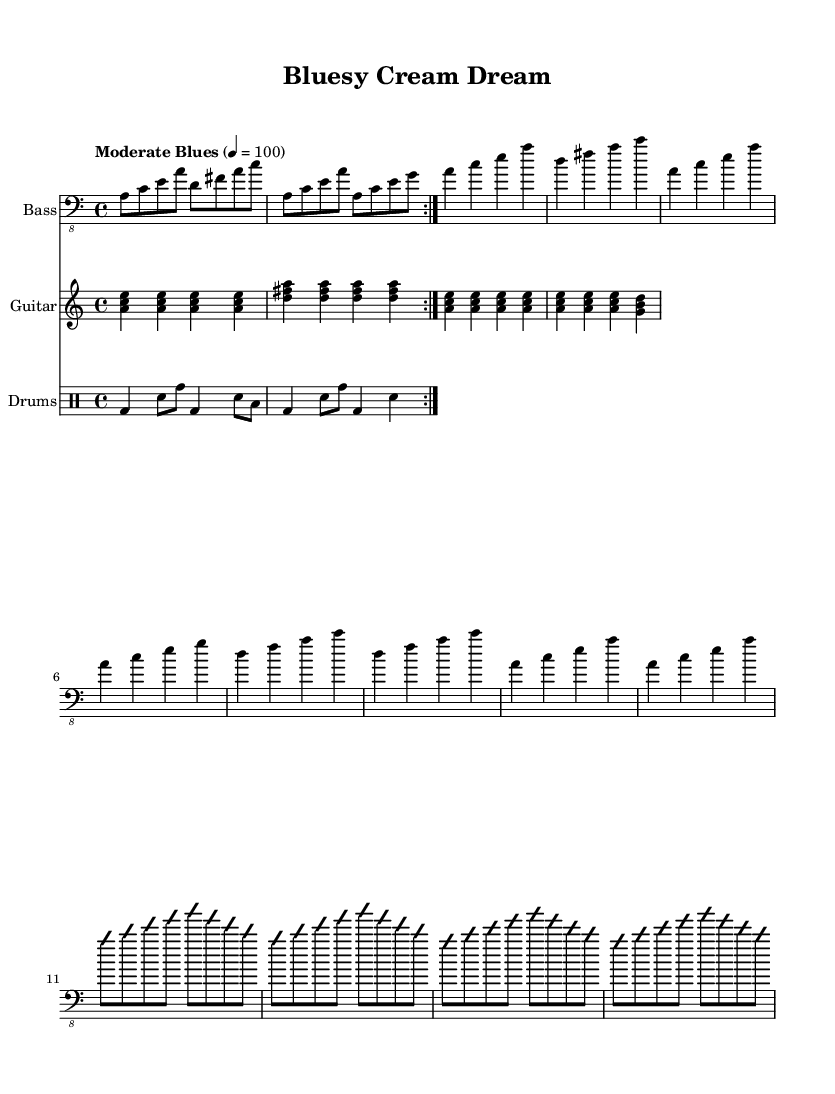What is the key signature of this music? The key signature is A minor, which has no sharps or flats. This is determined by checking the key indication at the beginning of the sheet music, which states 'a' for A minor.
Answer: A minor What is the time signature of the piece? The time signature is 4/4, indicating that there are four beats per measure, and the quarter note receives one beat. This can be found in the beginning part of the sheet music, right after the key signature.
Answer: 4/4 What is the tempo marking of the music? The tempo marking is "Moderate Blues", and it indicates a speed of 100 beats per minute. This is given at the beginning where it states the tempo with the respective speed indicated.
Answer: Moderate Blues How many bars are in the Intro/Bass Riff section? There are four bars in the Intro/Bass Riff section, which is repeated twice. Each repeat consists of a different sequence of notes but maintains the same structure, indicating a total of four bars.
Answer: 4 What type of progression is used in the Verse section? The Verse section uses a chord progression, which transitions between specific chords such as A minor, D minor, and G major. This can be discerned from the sequence of chords noted in the bass guitar part.
Answer: Chord progression How many bass solo measures are present in the score? There are four measures in the bass solo section as indicated by the notation that is to be improvised on. It contains two distinct phrases that each repeat once.
Answer: 4 What distinguishes the bass guitar part in this piece? The bass guitar part is characterized by prominent bass solos that showcase improvisation amidst structured riffing patterns. This is a distinctive feature of the Electric Blues genre, particularly in homage to the style of Jack Bruce.
Answer: Prominent bass solos 